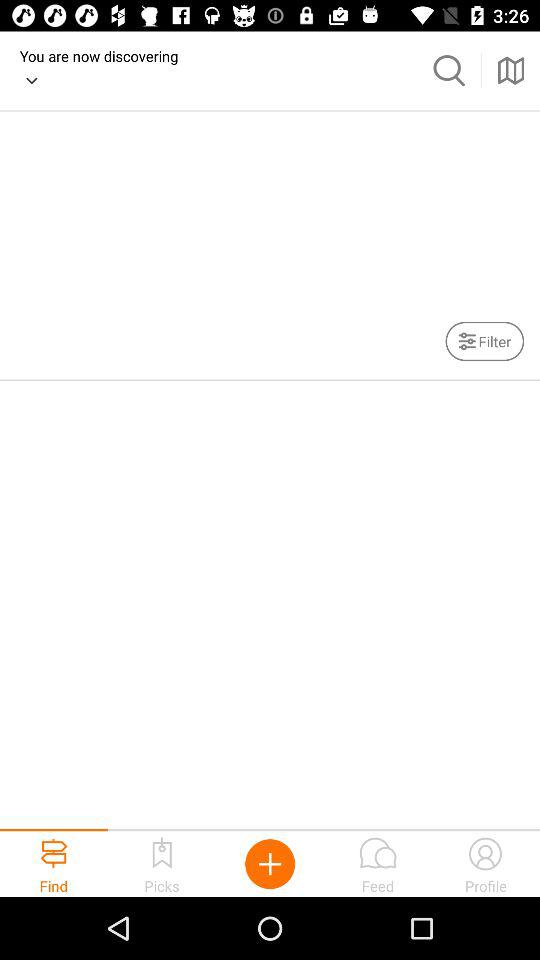Through what application can we log in? You can log in through "Facebook". 